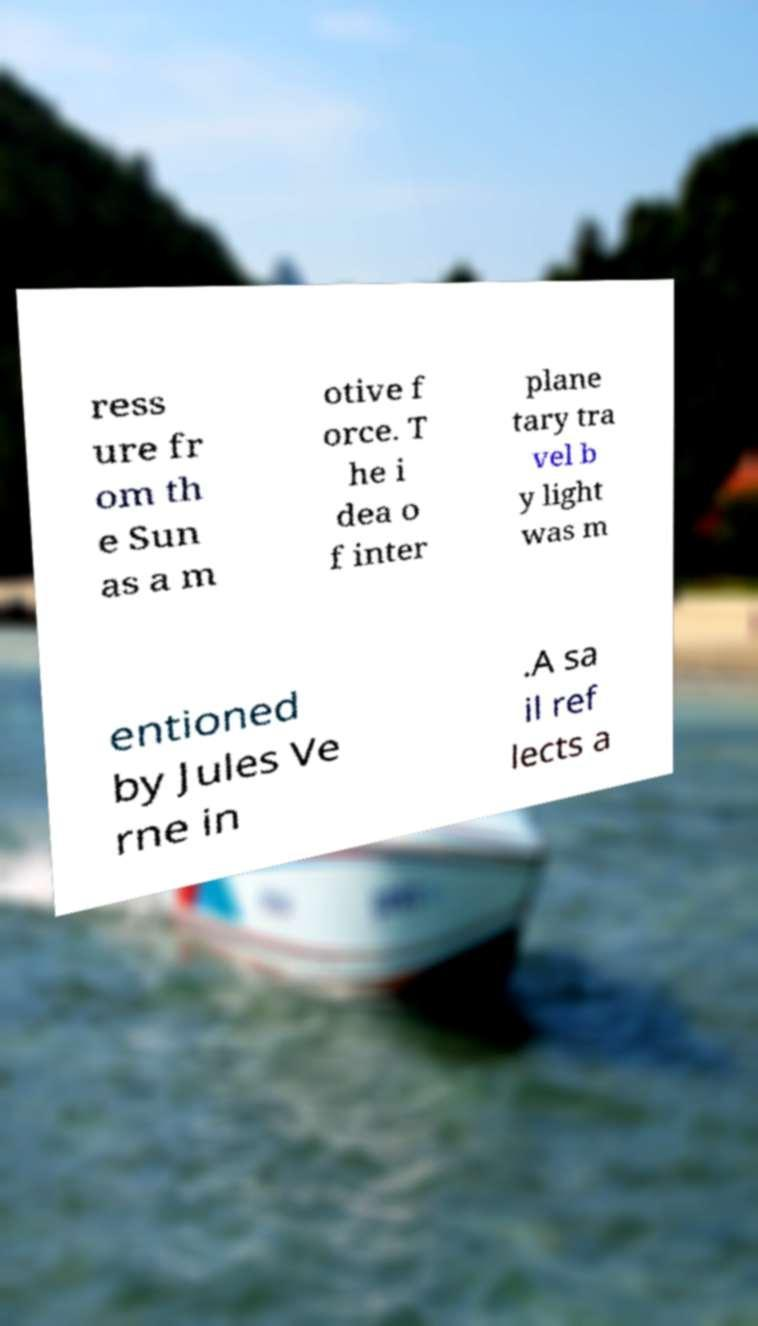Can you read and provide the text displayed in the image?This photo seems to have some interesting text. Can you extract and type it out for me? ress ure fr om th e Sun as a m otive f orce. T he i dea o f inter plane tary tra vel b y light was m entioned by Jules Ve rne in .A sa il ref lects a 